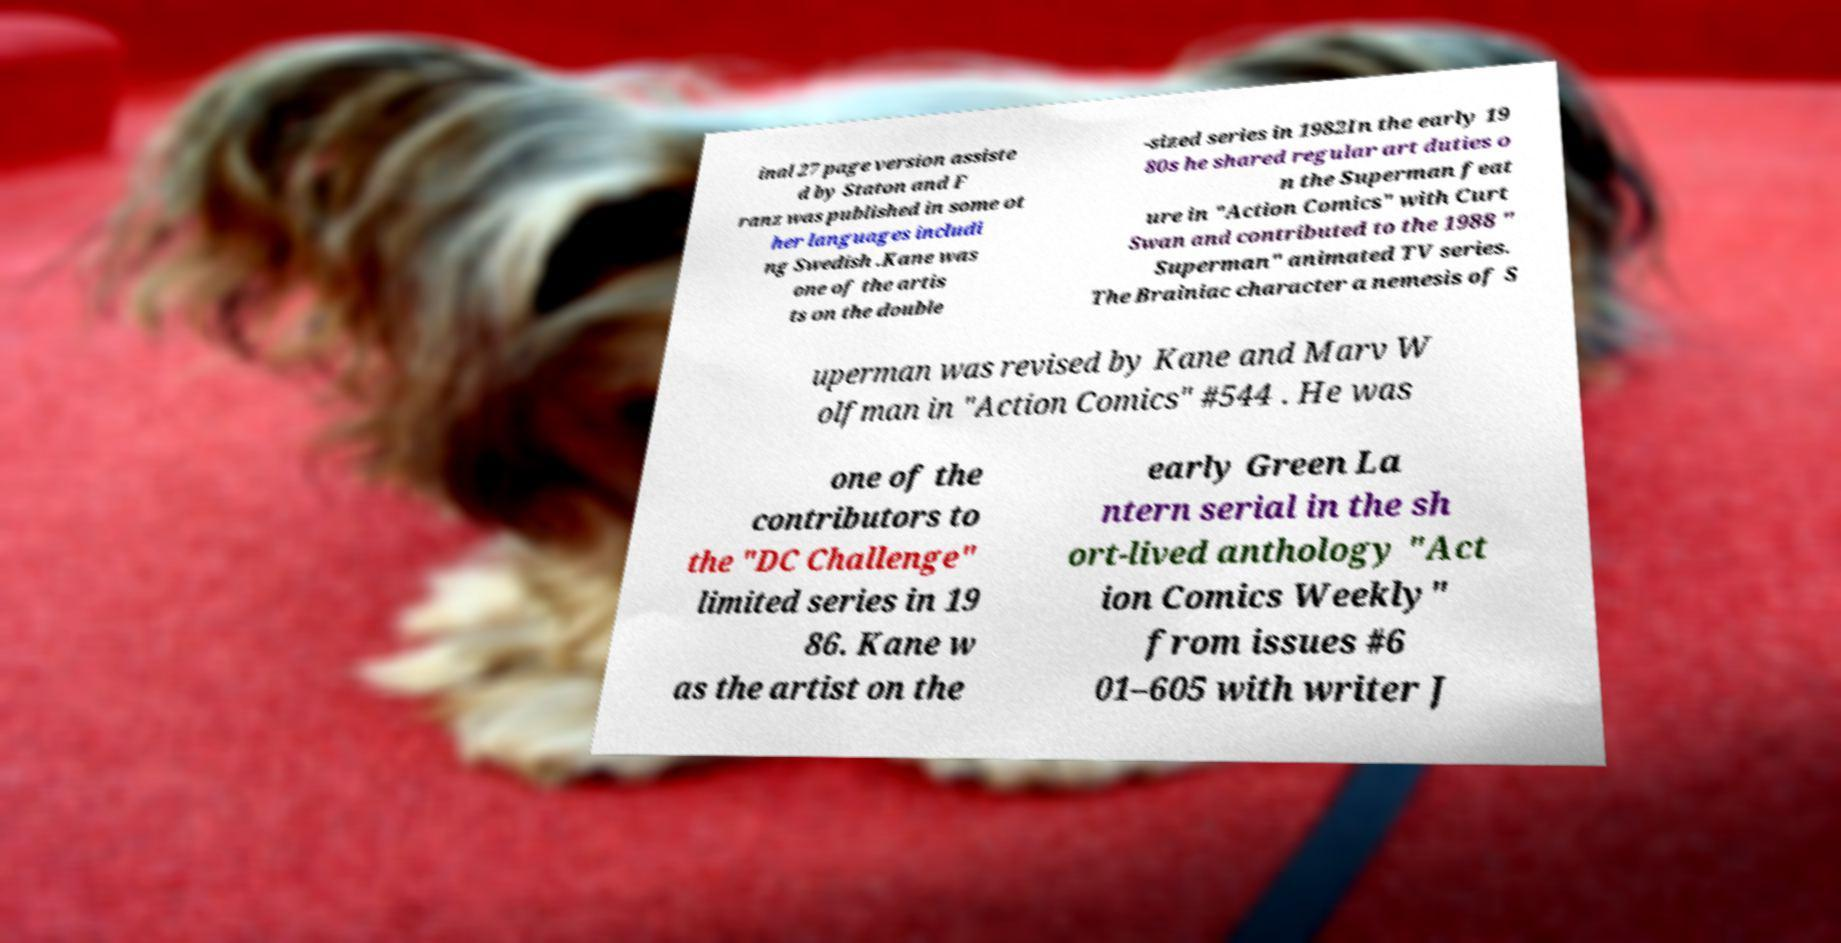Can you accurately transcribe the text from the provided image for me? inal 27 page version assiste d by Staton and F ranz was published in some ot her languages includi ng Swedish .Kane was one of the artis ts on the double -sized series in 1982In the early 19 80s he shared regular art duties o n the Superman feat ure in "Action Comics" with Curt Swan and contributed to the 1988 " Superman" animated TV series. The Brainiac character a nemesis of S uperman was revised by Kane and Marv W olfman in "Action Comics" #544 . He was one of the contributors to the "DC Challenge" limited series in 19 86. Kane w as the artist on the early Green La ntern serial in the sh ort-lived anthology "Act ion Comics Weekly" from issues #6 01–605 with writer J 